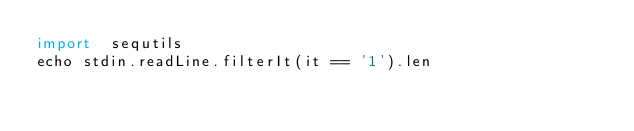<code> <loc_0><loc_0><loc_500><loc_500><_Nim_>import  sequtils
echo stdin.readLine.filterIt(it == '1').len

</code> 